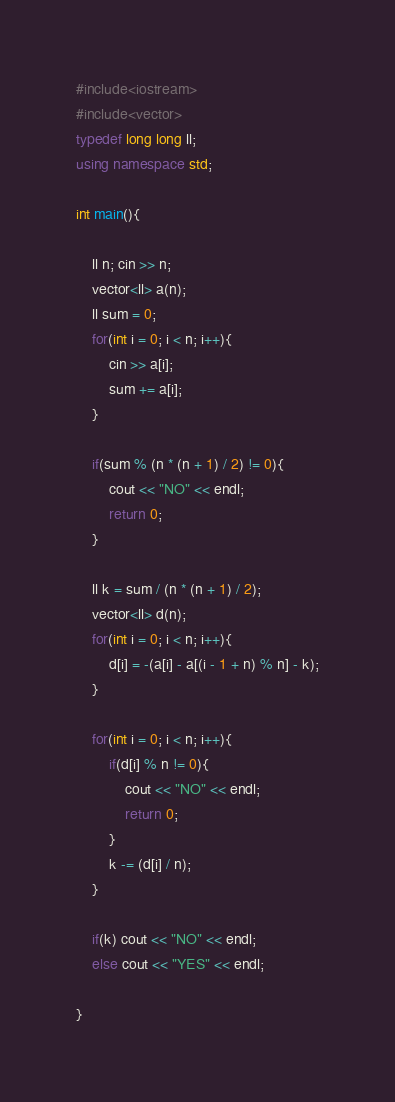Convert code to text. <code><loc_0><loc_0><loc_500><loc_500><_C++_>#include<iostream>
#include<vector>
typedef long long ll;
using namespace std;

int main(){

    ll n; cin >> n;
    vector<ll> a(n);
    ll sum = 0;
    for(int i = 0; i < n; i++){
        cin >> a[i];
        sum += a[i];
    }

    if(sum % (n * (n + 1) / 2) != 0){
        cout << "NO" << endl;
        return 0;
    }

    ll k = sum / (n * (n + 1) / 2);
    vector<ll> d(n);
    for(int i = 0; i < n; i++){
        d[i] = -(a[i] - a[(i - 1 + n) % n] - k);
    }

    for(int i = 0; i < n; i++){
        if(d[i] % n != 0){
            cout << "NO" << endl;
            return 0;
        }
        k -= (d[i] / n);
    }

    if(k) cout << "NO" << endl;
    else cout << "YES" << endl;
    
}</code> 